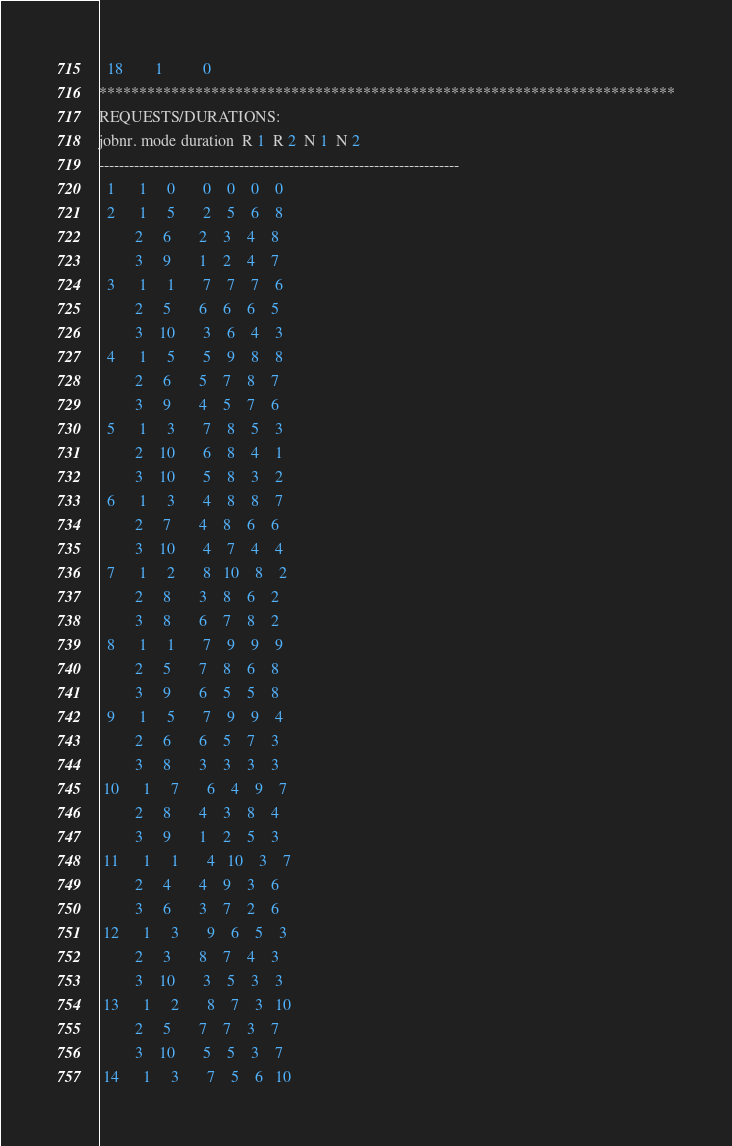Convert code to text. <code><loc_0><loc_0><loc_500><loc_500><_ObjectiveC_>  18        1          0        
************************************************************************
REQUESTS/DURATIONS:
jobnr. mode duration  R 1  R 2  N 1  N 2
------------------------------------------------------------------------
  1      1     0       0    0    0    0
  2      1     5       2    5    6    8
         2     6       2    3    4    8
         3     9       1    2    4    7
  3      1     1       7    7    7    6
         2     5       6    6    6    5
         3    10       3    6    4    3
  4      1     5       5    9    8    8
         2     6       5    7    8    7
         3     9       4    5    7    6
  5      1     3       7    8    5    3
         2    10       6    8    4    1
         3    10       5    8    3    2
  6      1     3       4    8    8    7
         2     7       4    8    6    6
         3    10       4    7    4    4
  7      1     2       8   10    8    2
         2     8       3    8    6    2
         3     8       6    7    8    2
  8      1     1       7    9    9    9
         2     5       7    8    6    8
         3     9       6    5    5    8
  9      1     5       7    9    9    4
         2     6       6    5    7    3
         3     8       3    3    3    3
 10      1     7       6    4    9    7
         2     8       4    3    8    4
         3     9       1    2    5    3
 11      1     1       4   10    3    7
         2     4       4    9    3    6
         3     6       3    7    2    6
 12      1     3       9    6    5    3
         2     3       8    7    4    3
         3    10       3    5    3    3
 13      1     2       8    7    3   10
         2     5       7    7    3    7
         3    10       5    5    3    7
 14      1     3       7    5    6   10</code> 